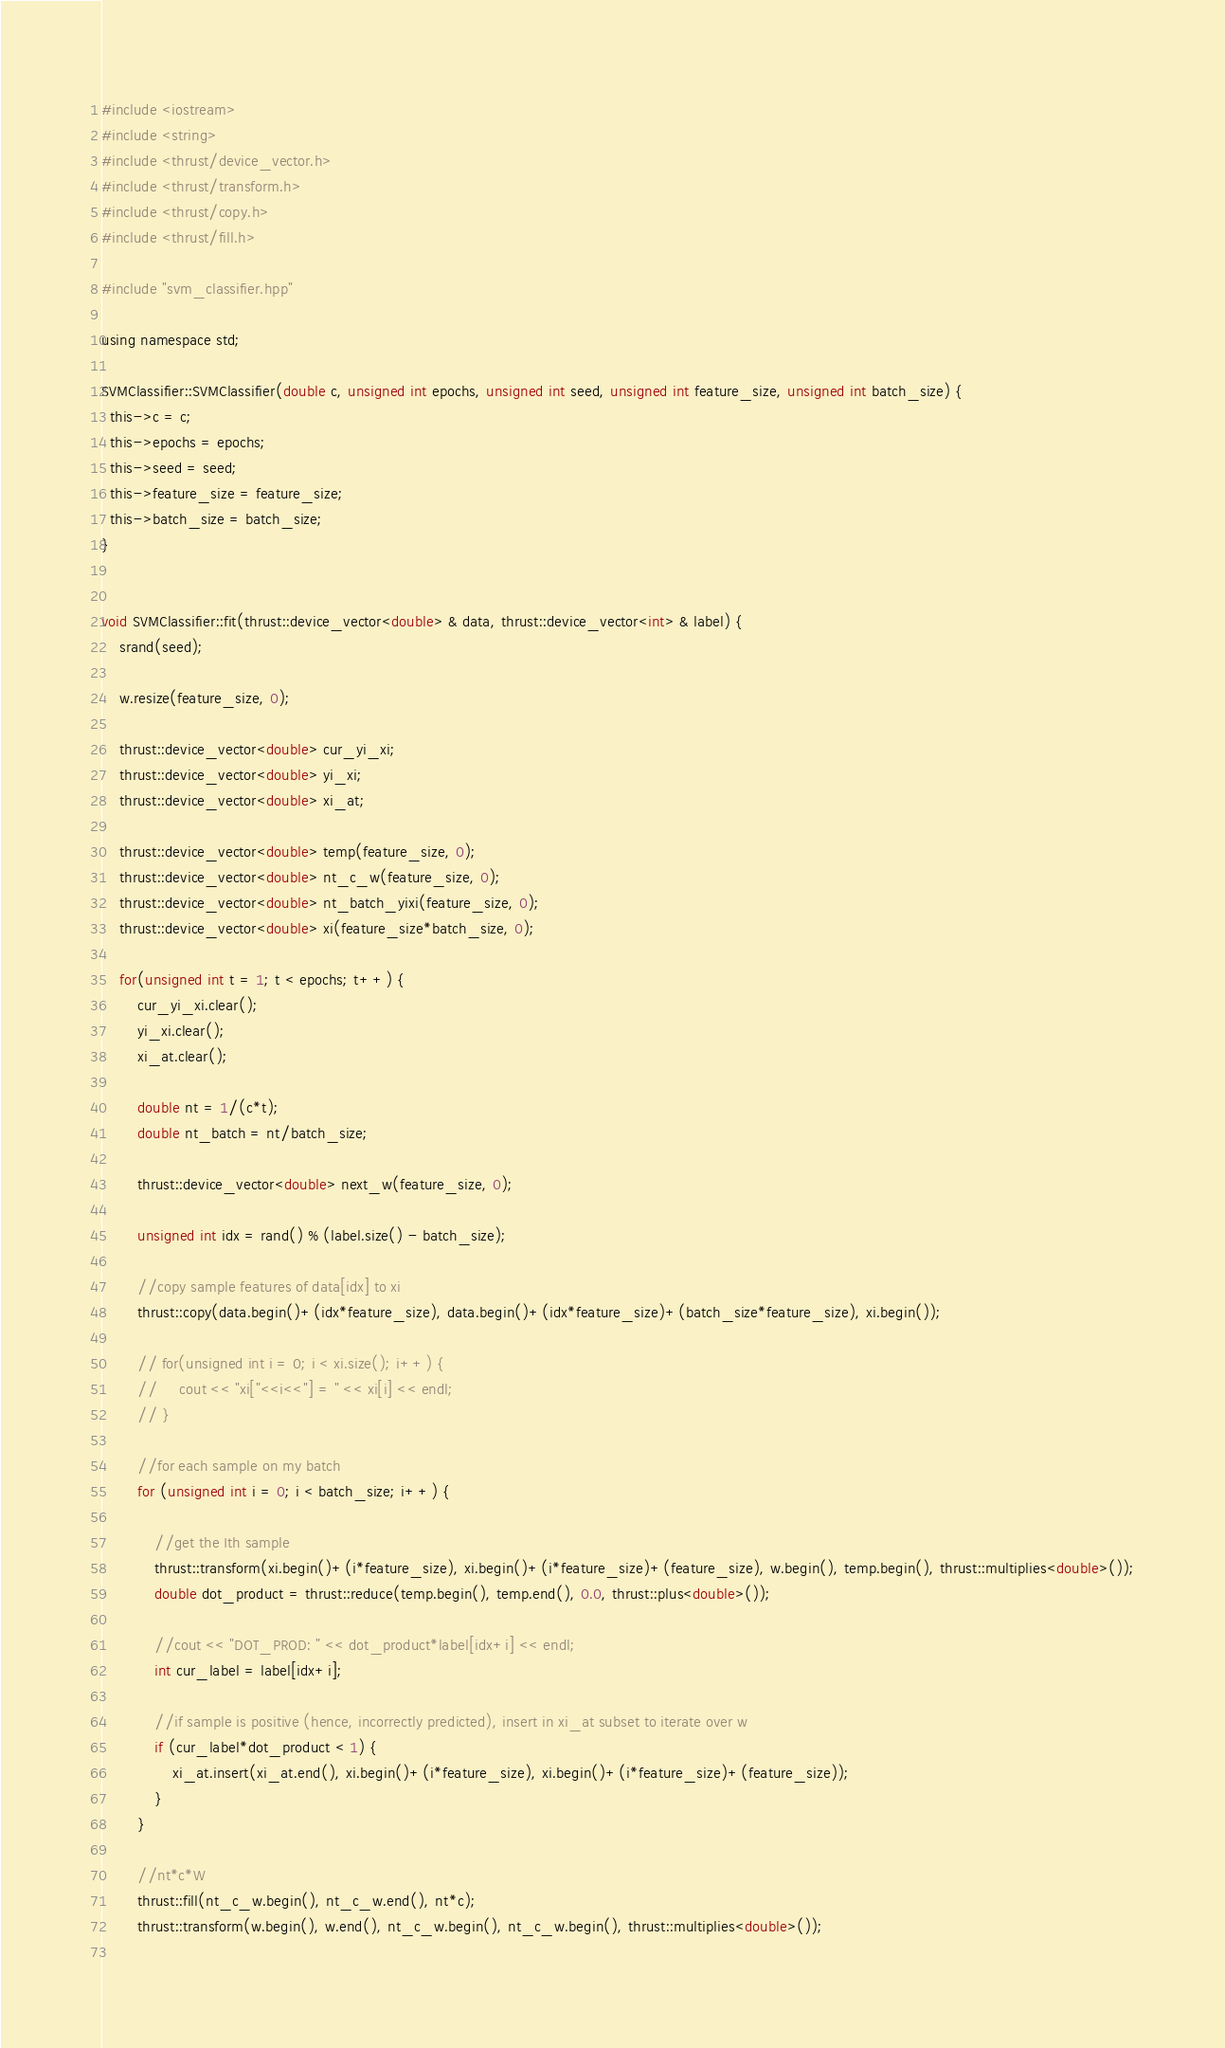<code> <loc_0><loc_0><loc_500><loc_500><_Cuda_>#include <iostream>
#include <string>
#include <thrust/device_vector.h>
#include <thrust/transform.h>
#include <thrust/copy.h>
#include <thrust/fill.h>

#include "svm_classifier.hpp"

using namespace std;

SVMClassifier::SVMClassifier(double c, unsigned int epochs, unsigned int seed, unsigned int feature_size, unsigned int batch_size) {
  this->c = c;
  this->epochs = epochs;
  this->seed = seed;
  this->feature_size = feature_size;
  this->batch_size = batch_size;
}


void SVMClassifier::fit(thrust::device_vector<double> & data, thrust::device_vector<int> & label) {
    srand(seed);  
    
    w.resize(feature_size, 0);

    thrust::device_vector<double> cur_yi_xi;
    thrust::device_vector<double> yi_xi;
    thrust::device_vector<double> xi_at;

    thrust::device_vector<double> temp(feature_size, 0);
    thrust::device_vector<double> nt_c_w(feature_size, 0);
    thrust::device_vector<double> nt_batch_yixi(feature_size, 0);
    thrust::device_vector<double> xi(feature_size*batch_size, 0); 

    for(unsigned int t = 1; t < epochs; t++) {
        cur_yi_xi.clear();
        yi_xi.clear();
        xi_at.clear();

        double nt = 1/(c*t);
        double nt_batch = nt/batch_size;    

        thrust::device_vector<double> next_w(feature_size, 0);
        
        unsigned int idx = rand() % (label.size() - batch_size);
 
        //copy sample features of data[idx] to xi
        thrust::copy(data.begin()+(idx*feature_size), data.begin()+(idx*feature_size)+(batch_size*feature_size), xi.begin());
        
        // for(unsigned int i = 0; i < xi.size(); i++) {
        //     cout << "xi["<<i<<"] = " << xi[i] << endl;
        // }

        //for each sample on my batch
        for (unsigned int i = 0; i < batch_size; i++) {
            
            //get the Ith sample
            thrust::transform(xi.begin()+(i*feature_size), xi.begin()+(i*feature_size)+(feature_size), w.begin(), temp.begin(), thrust::multiplies<double>());
            double dot_product = thrust::reduce(temp.begin(), temp.end(), 0.0, thrust::plus<double>());
            
            //cout << "DOT_PROD: " << dot_product*label[idx+i] << endl;
            int cur_label = label[idx+i];
            
            //if sample is positive (hence, incorrectly predicted), insert in xi_at subset to iterate over w
            if (cur_label*dot_product < 1) {
                xi_at.insert(xi_at.end(), xi.begin()+(i*feature_size), xi.begin()+(i*feature_size)+(feature_size));
            }
        }
        
        //nt*c*W
        thrust::fill(nt_c_w.begin(), nt_c_w.end(), nt*c);
        thrust::transform(w.begin(), w.end(), nt_c_w.begin(), nt_c_w.begin(), thrust::multiplies<double>());
        </code> 